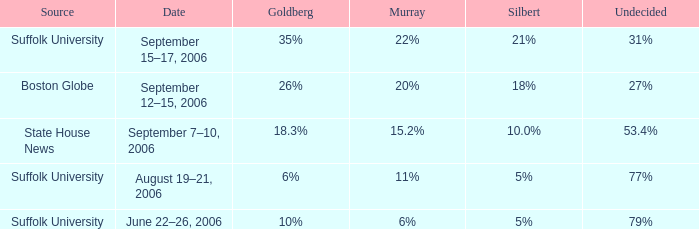What is the date of the survey with silbert at 1 September 7–10, 2006. 